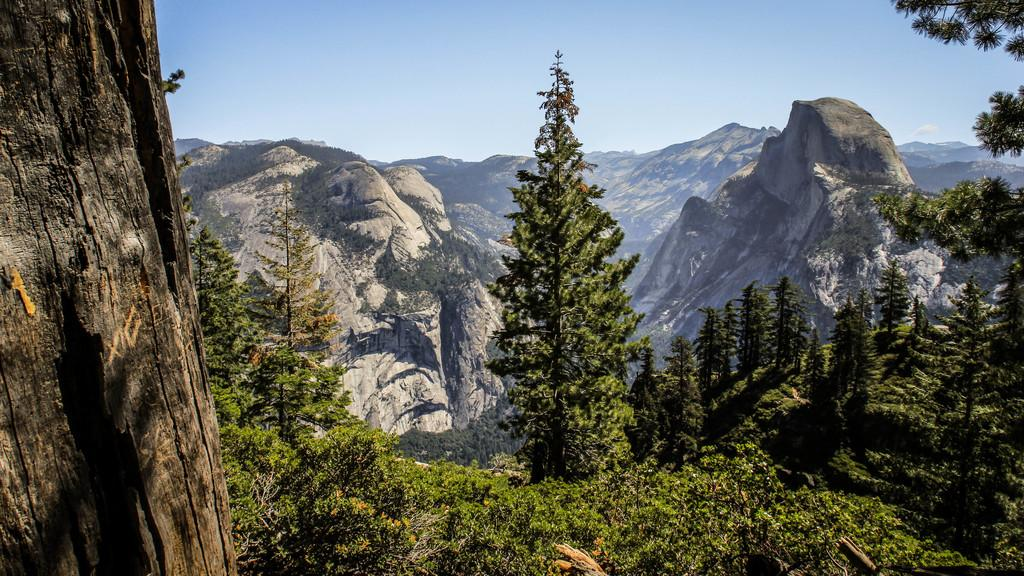What type of vegetation can be seen in the image? There are trees in the image. What can be seen in the distance in the image? There are hills visible in the background of the image. What is visible in the sky in the background of the image? There are clouds in the sky in the background of the image. What type of harmony is being played by the laborer in the image? There is no laborer or harmony present in the image; it features trees, hills, and clouds. How many eggs can be seen in the image? There are no eggs present in the image. 